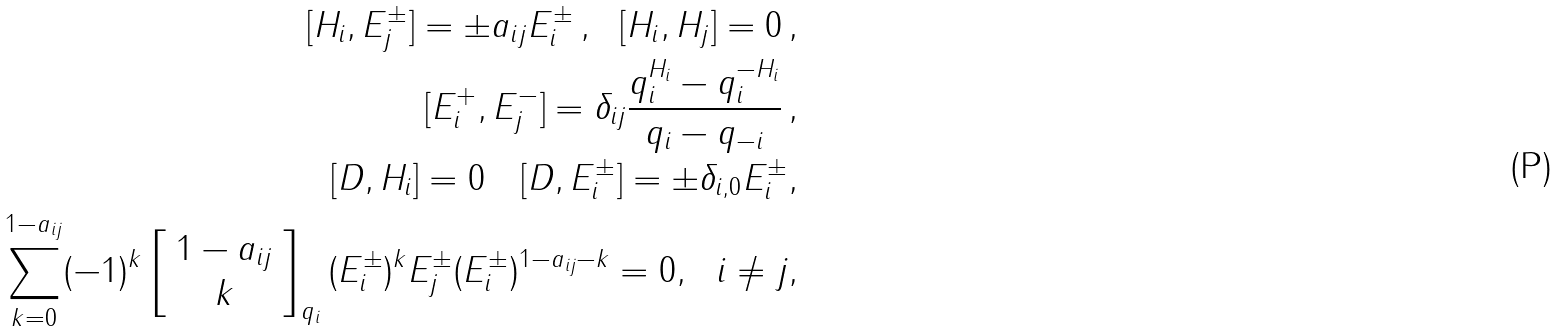<formula> <loc_0><loc_0><loc_500><loc_500>[ H _ { i } , E ^ { \pm } _ { j } ] = \pm a _ { i j } E ^ { \pm } _ { i } \, , \ \ [ H _ { i } , H _ { j } ] = 0 \, , \\ [ E ^ { + } _ { i } , E ^ { - } _ { j } ] = \delta _ { i j } \frac { q _ { i } ^ { H _ { i } } - q _ { i } ^ { - H _ { i } } } { q _ { i } - q _ { - i } } \, , \\ [ D , H _ { i } ] = 0 \quad [ D , E ^ { \pm } _ { i } ] = \pm \delta _ { i , 0 } E ^ { \pm } _ { i } , \\ \sum _ { k = 0 } ^ { 1 - a _ { i j } } ( - 1 ) ^ { k } \left [ \begin{array} { c } 1 - a _ { i j } \\ k \end{array} \right ] _ { q _ { i } } ( E _ { i } ^ { \pm } ) ^ { k } E _ { j } ^ { \pm } ( E _ { i } ^ { \pm } ) ^ { 1 - a _ { i j } - k } = 0 , \ \ i \neq j ,</formula> 